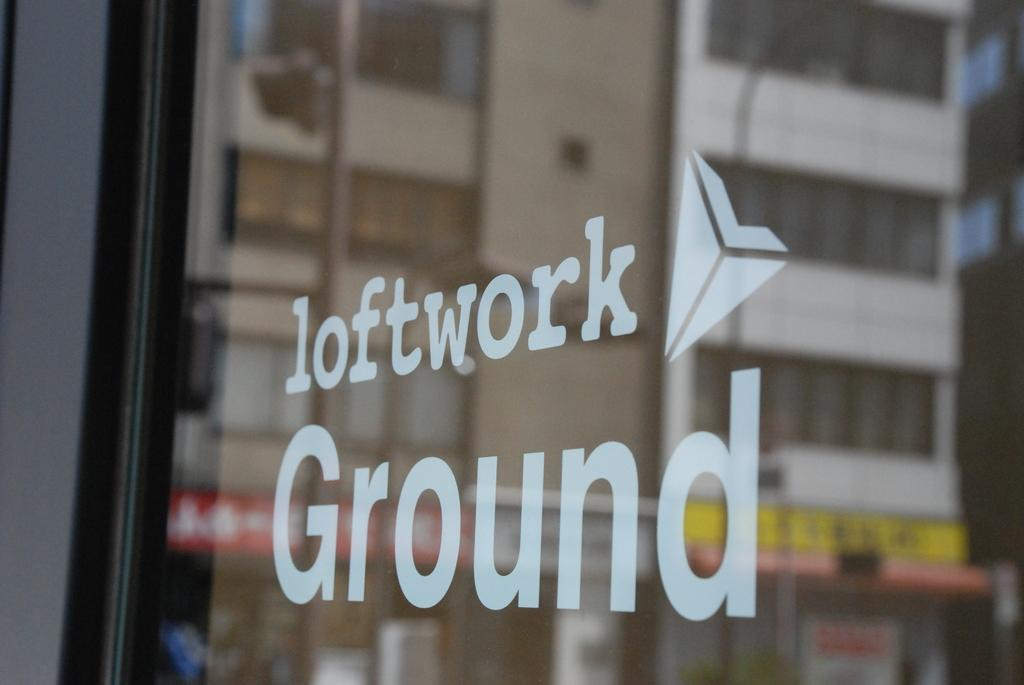What object is present in the image that can hold a liquid? There is a glass in the image. What is written or printed on the glass? There is text on the glass. What can be seen through the glass in the image? Buildings are visible through the glass. What type of yak can be seen grazing in the background of the image? There is no yak present in the image; it features a glass with text and buildings visible through it. 